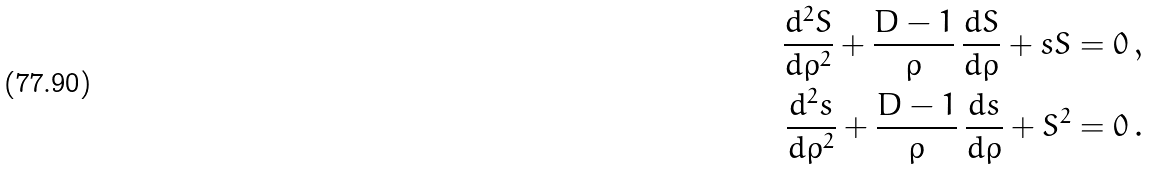Convert formula to latex. <formula><loc_0><loc_0><loc_500><loc_500>\frac { d ^ { 2 } S } { d \rho ^ { 2 } } + \frac { D - 1 } { \rho } \, \frac { d S } { d \rho } + s S & = 0 \, , \\ \frac { d ^ { 2 } s } { d \rho ^ { 2 } } + \frac { D - 1 } { \rho } \, \frac { d s } { d \rho } + S ^ { 2 } & = 0 \, .</formula> 